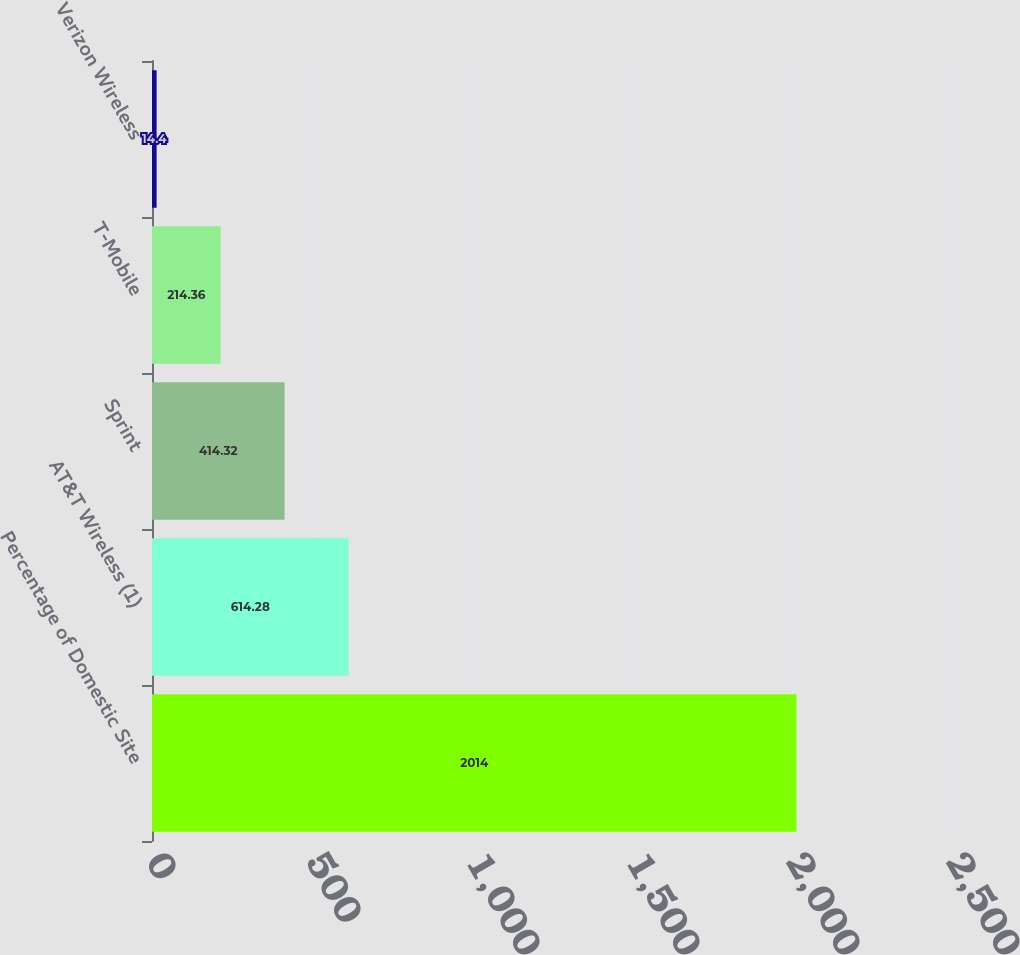<chart> <loc_0><loc_0><loc_500><loc_500><bar_chart><fcel>Percentage of Domestic Site<fcel>AT&T Wireless (1)<fcel>Sprint<fcel>T-Mobile<fcel>Verizon Wireless<nl><fcel>2014<fcel>614.28<fcel>414.32<fcel>214.36<fcel>14.4<nl></chart> 